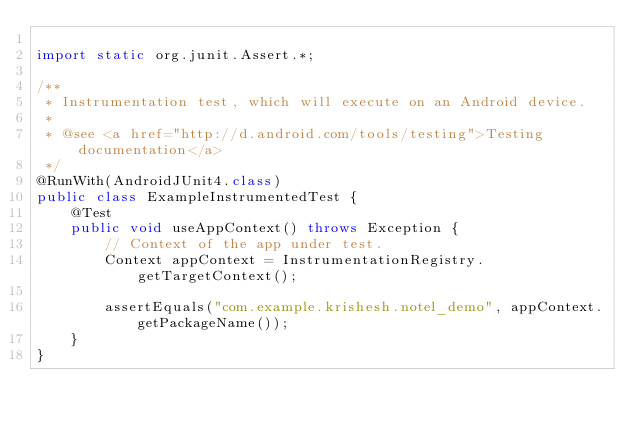Convert code to text. <code><loc_0><loc_0><loc_500><loc_500><_Java_>
import static org.junit.Assert.*;

/**
 * Instrumentation test, which will execute on an Android device.
 *
 * @see <a href="http://d.android.com/tools/testing">Testing documentation</a>
 */
@RunWith(AndroidJUnit4.class)
public class ExampleInstrumentedTest {
    @Test
    public void useAppContext() throws Exception {
        // Context of the app under test.
        Context appContext = InstrumentationRegistry.getTargetContext();

        assertEquals("com.example.krishesh.notel_demo", appContext.getPackageName());
    }
}
</code> 